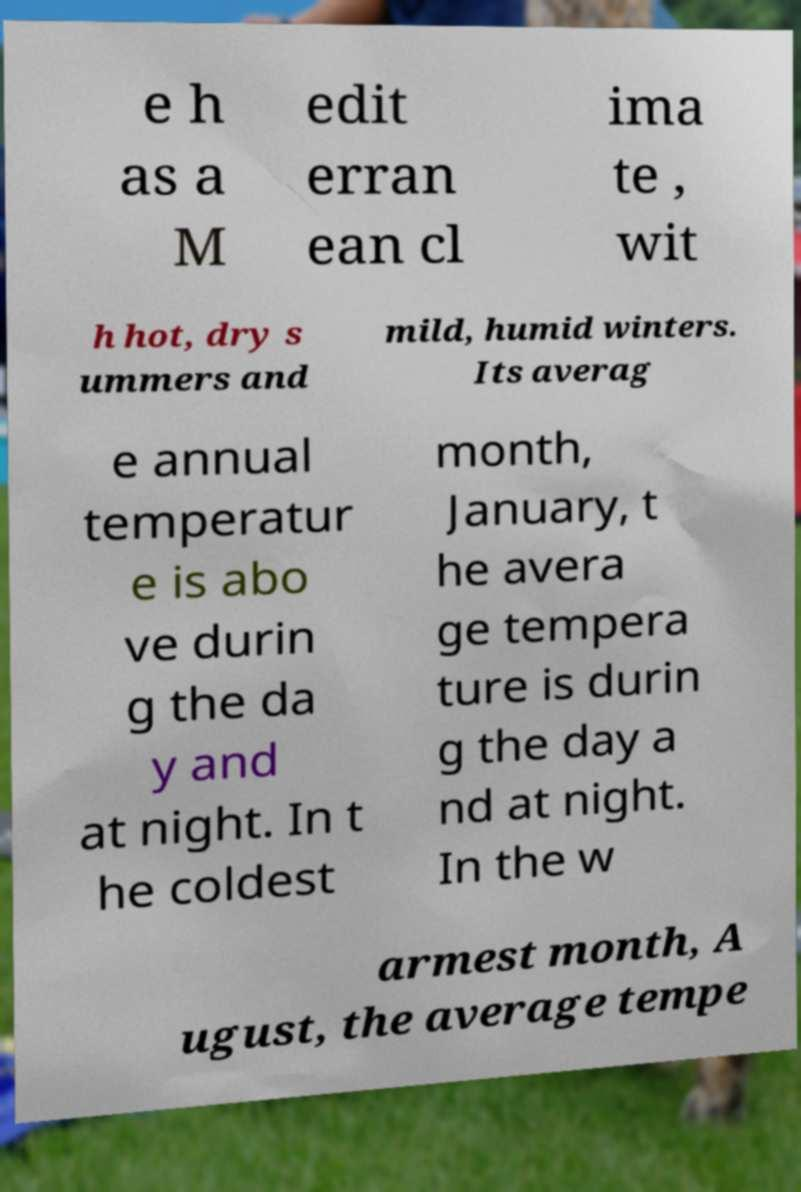Can you accurately transcribe the text from the provided image for me? e h as a M edit erran ean cl ima te , wit h hot, dry s ummers and mild, humid winters. Its averag e annual temperatur e is abo ve durin g the da y and at night. In t he coldest month, January, t he avera ge tempera ture is durin g the day a nd at night. In the w armest month, A ugust, the average tempe 